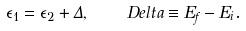<formula> <loc_0><loc_0><loc_500><loc_500>\epsilon _ { 1 } = \epsilon _ { 2 } + \Delta , \quad D e l t a \equiv E _ { f } - E _ { i } .</formula> 